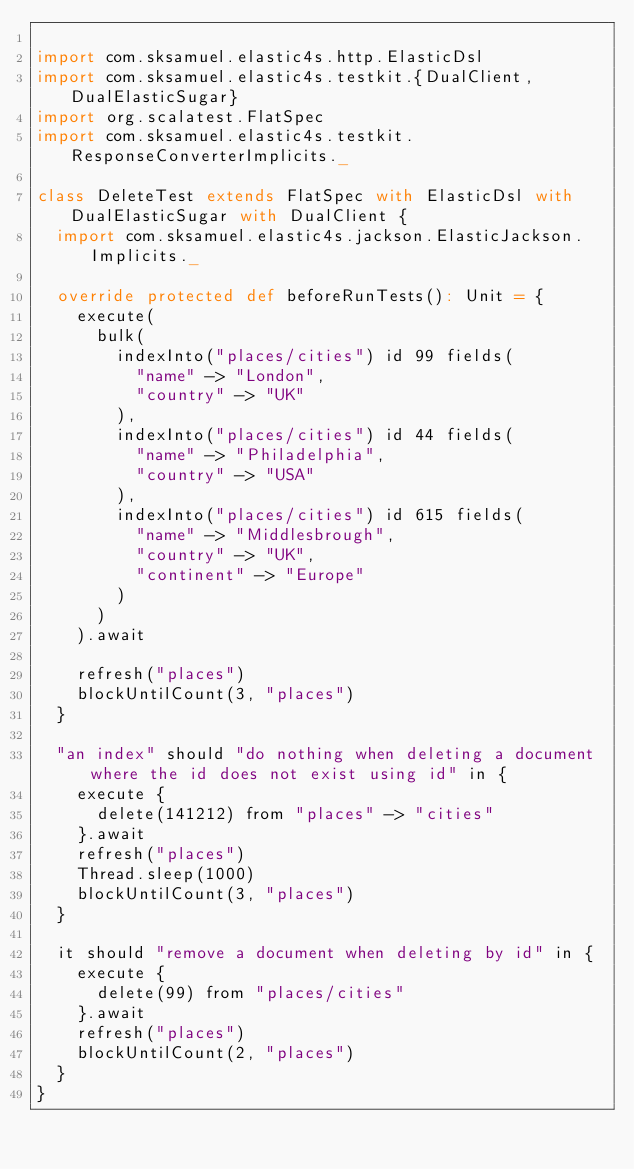<code> <loc_0><loc_0><loc_500><loc_500><_Scala_>
import com.sksamuel.elastic4s.http.ElasticDsl
import com.sksamuel.elastic4s.testkit.{DualClient, DualElasticSugar}
import org.scalatest.FlatSpec
import com.sksamuel.elastic4s.testkit.ResponseConverterImplicits._

class DeleteTest extends FlatSpec with ElasticDsl with DualElasticSugar with DualClient {
  import com.sksamuel.elastic4s.jackson.ElasticJackson.Implicits._

  override protected def beforeRunTests(): Unit = {
    execute(
      bulk(
        indexInto("places/cities") id 99 fields(
          "name" -> "London",
          "country" -> "UK"
        ),
        indexInto("places/cities") id 44 fields(
          "name" -> "Philadelphia",
          "country" -> "USA"
        ),
        indexInto("places/cities") id 615 fields(
          "name" -> "Middlesbrough",
          "country" -> "UK",
          "continent" -> "Europe"
        )
      )
    ).await

    refresh("places")
    blockUntilCount(3, "places")
  }

  "an index" should "do nothing when deleting a document where the id does not exist using id" in {
    execute {
      delete(141212) from "places" -> "cities"
    }.await
    refresh("places")
    Thread.sleep(1000)
    blockUntilCount(3, "places")
  }

  it should "remove a document when deleting by id" in {
    execute {
      delete(99) from "places/cities"
    }.await
    refresh("places")
    blockUntilCount(2, "places")
  }
}
</code> 